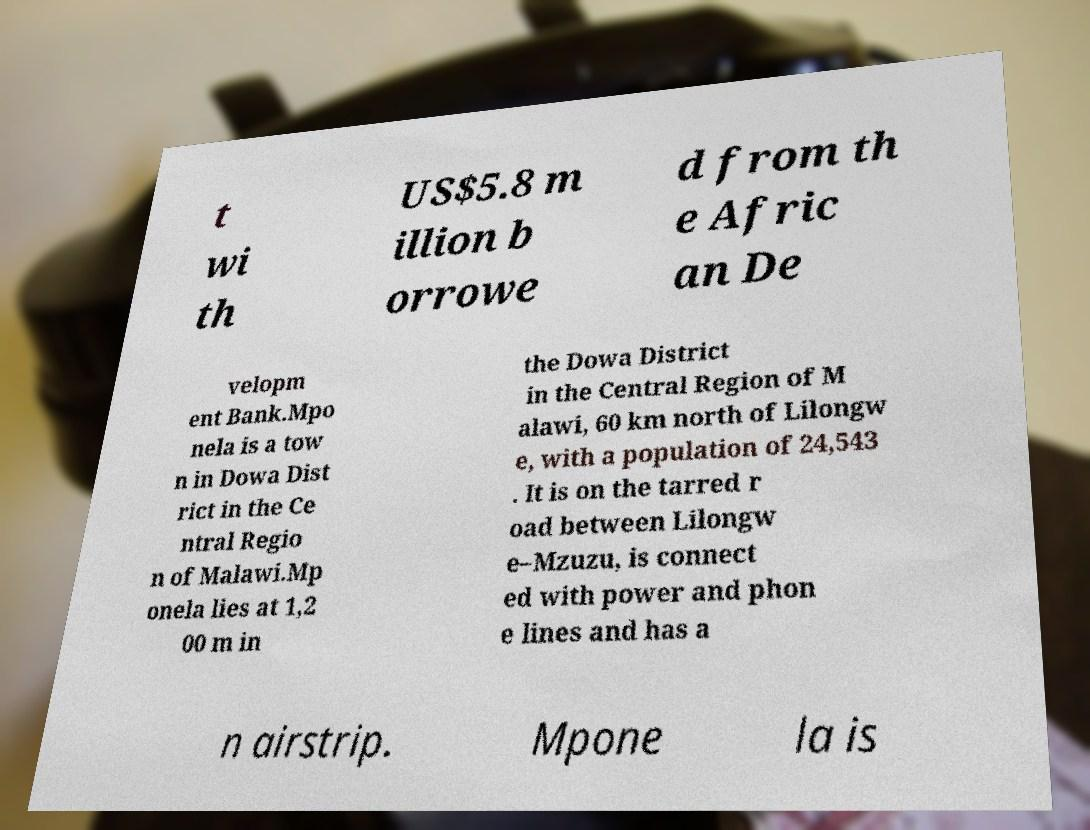There's text embedded in this image that I need extracted. Can you transcribe it verbatim? t wi th US$5.8 m illion b orrowe d from th e Afric an De velopm ent Bank.Mpo nela is a tow n in Dowa Dist rict in the Ce ntral Regio n of Malawi.Mp onela lies at 1,2 00 m in the Dowa District in the Central Region of M alawi, 60 km north of Lilongw e, with a population of 24,543 . It is on the tarred r oad between Lilongw e–Mzuzu, is connect ed with power and phon e lines and has a n airstrip. Mpone la is 